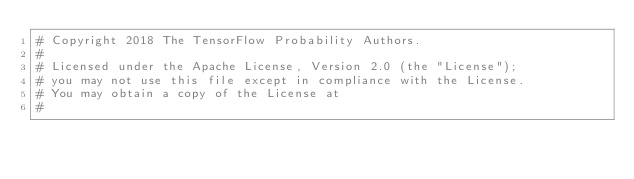Convert code to text. <code><loc_0><loc_0><loc_500><loc_500><_Python_># Copyright 2018 The TensorFlow Probability Authors.
#
# Licensed under the Apache License, Version 2.0 (the "License");
# you may not use this file except in compliance with the License.
# You may obtain a copy of the License at
#</code> 